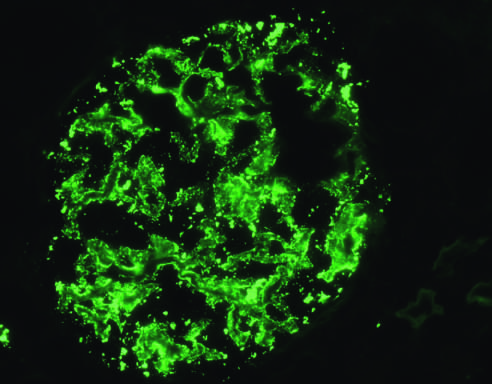how is deposition of igg antibody in a granular pattern detected?
Answer the question using a single word or phrase. By immunofluorescence 